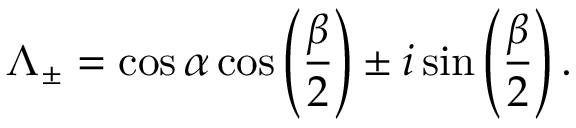Convert formula to latex. <formula><loc_0><loc_0><loc_500><loc_500>\Lambda _ { \pm } = \cos \alpha \cos \left ( \frac { \beta } { 2 } \right ) \pm i \sin \left ( \frac { \beta } { 2 } \right ) .</formula> 